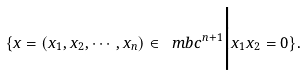Convert formula to latex. <formula><loc_0><loc_0><loc_500><loc_500>\{ x = ( x _ { 1 } , x _ { 2 } , \cdots , x _ { n } ) \in \ m b c ^ { n + 1 } \Big { | } x _ { 1 } x _ { 2 } = 0 \} .</formula> 